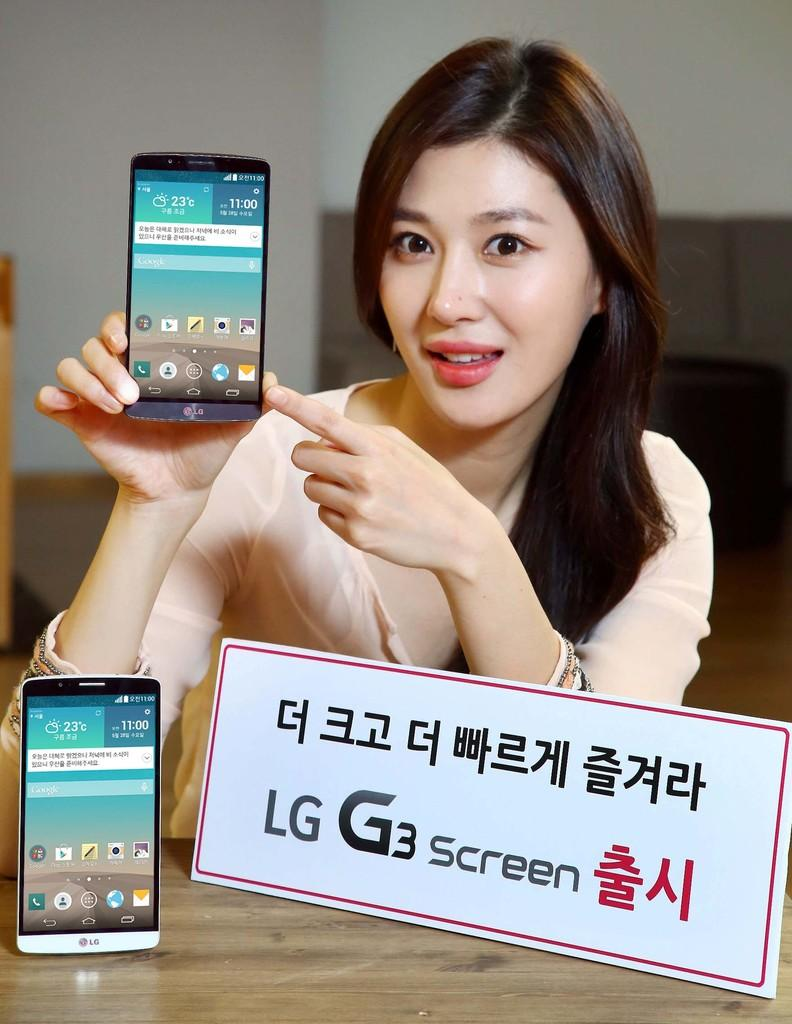<image>
Summarize the visual content of the image. An advertisement showing a woman for the cell phone LG G3 screen. 